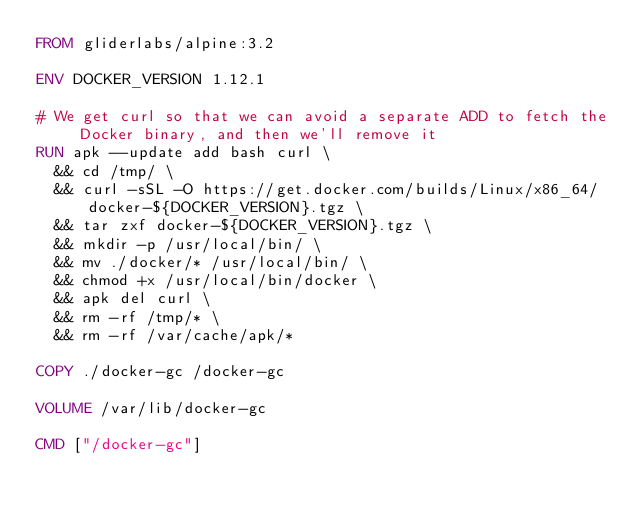<code> <loc_0><loc_0><loc_500><loc_500><_Dockerfile_>FROM gliderlabs/alpine:3.2

ENV DOCKER_VERSION 1.12.1

# We get curl so that we can avoid a separate ADD to fetch the Docker binary, and then we'll remove it
RUN apk --update add bash curl \
  && cd /tmp/ \
  && curl -sSL -O https://get.docker.com/builds/Linux/x86_64/docker-${DOCKER_VERSION}.tgz \
  && tar zxf docker-${DOCKER_VERSION}.tgz \
  && mkdir -p /usr/local/bin/ \
  && mv ./docker/* /usr/local/bin/ \
  && chmod +x /usr/local/bin/docker \
  && apk del curl \
  && rm -rf /tmp/* \
  && rm -rf /var/cache/apk/*

COPY ./docker-gc /docker-gc

VOLUME /var/lib/docker-gc

CMD ["/docker-gc"]
</code> 